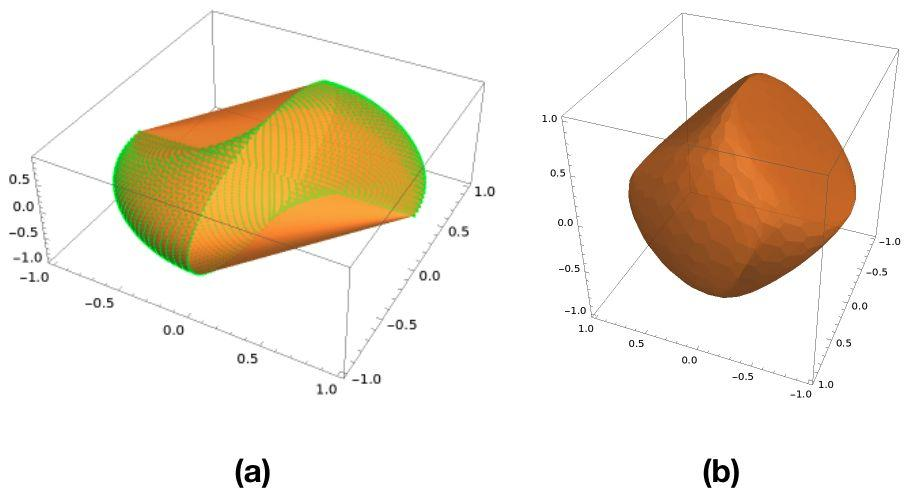What characteristic of the surface in Figure (a) distinguishes it from the surface in Figure (b)? A. Figure (a) has a flat surface, while Figure (b) has a curved surface. B. Figure (a) is a two-dimensional plot, while Figure (b) is a three-dimensional plot. C. Figure (a) shows a surface with only positive z-values, while Figure (b) includes both positive and negative z-values. D. Figure (a) shows a sinusoidal pattern, while Figure (b) is a solid without a visible pattern. The distinct difference between the surfaces in Figures (a) and (b) lies predominantly in the pattern visible on their surfaces. Figure (a) exhibits a clear sinusoidal pattern characterized by alternating colors that represent varying heights, signaling a dynamic surface topology. In contrast, Figure (b) presents a solid, uniform appearance with no discernible pattern, reflecting a smooth and consistent height. This observation aligns with option D, highlighting the contrasting designs of the two surfaces, making it easier for students or professionals examining the graphics to understand variations in their geometrical features. 